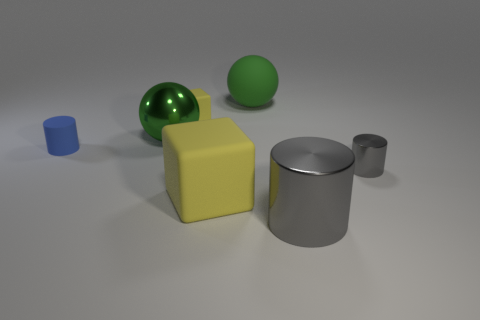Add 2 large cylinders. How many objects exist? 9 Subtract all spheres. How many objects are left? 5 Add 1 tiny cylinders. How many tiny cylinders are left? 3 Add 6 yellow rubber cylinders. How many yellow rubber cylinders exist? 6 Subtract 0 purple cubes. How many objects are left? 7 Subtract all small yellow matte objects. Subtract all gray metallic cylinders. How many objects are left? 4 